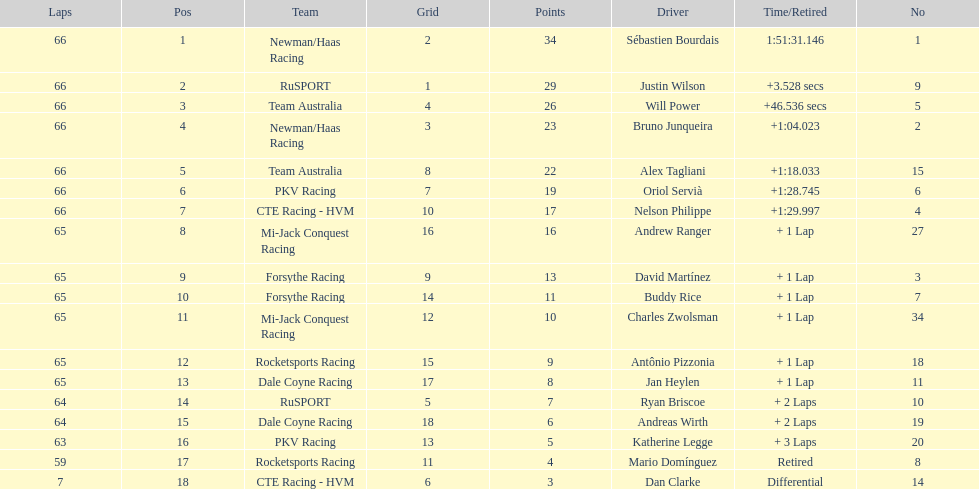Who finished directly after the driver who finished in 1:28.745? Nelson Philippe. 